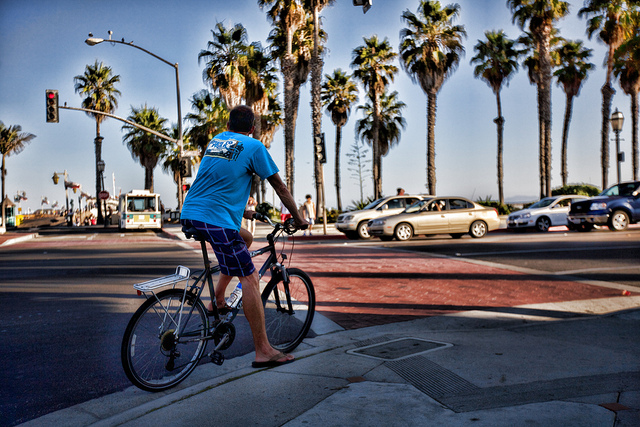What kind of transportation is shown?
A. air
B. road
C. rail
D. water
Answer with the option's letter from the given choices directly. The image depicts B. road transportation, as we can see an individual about to embark on a journey using a bicycle, a mode of transport well-suited for road travel. The presence of cars and a bus in the background further confirms that the setting is associated with road transport, common in urban and suburban surroundings where such vehicles share the infrastructure for travel and commuting purposes. 